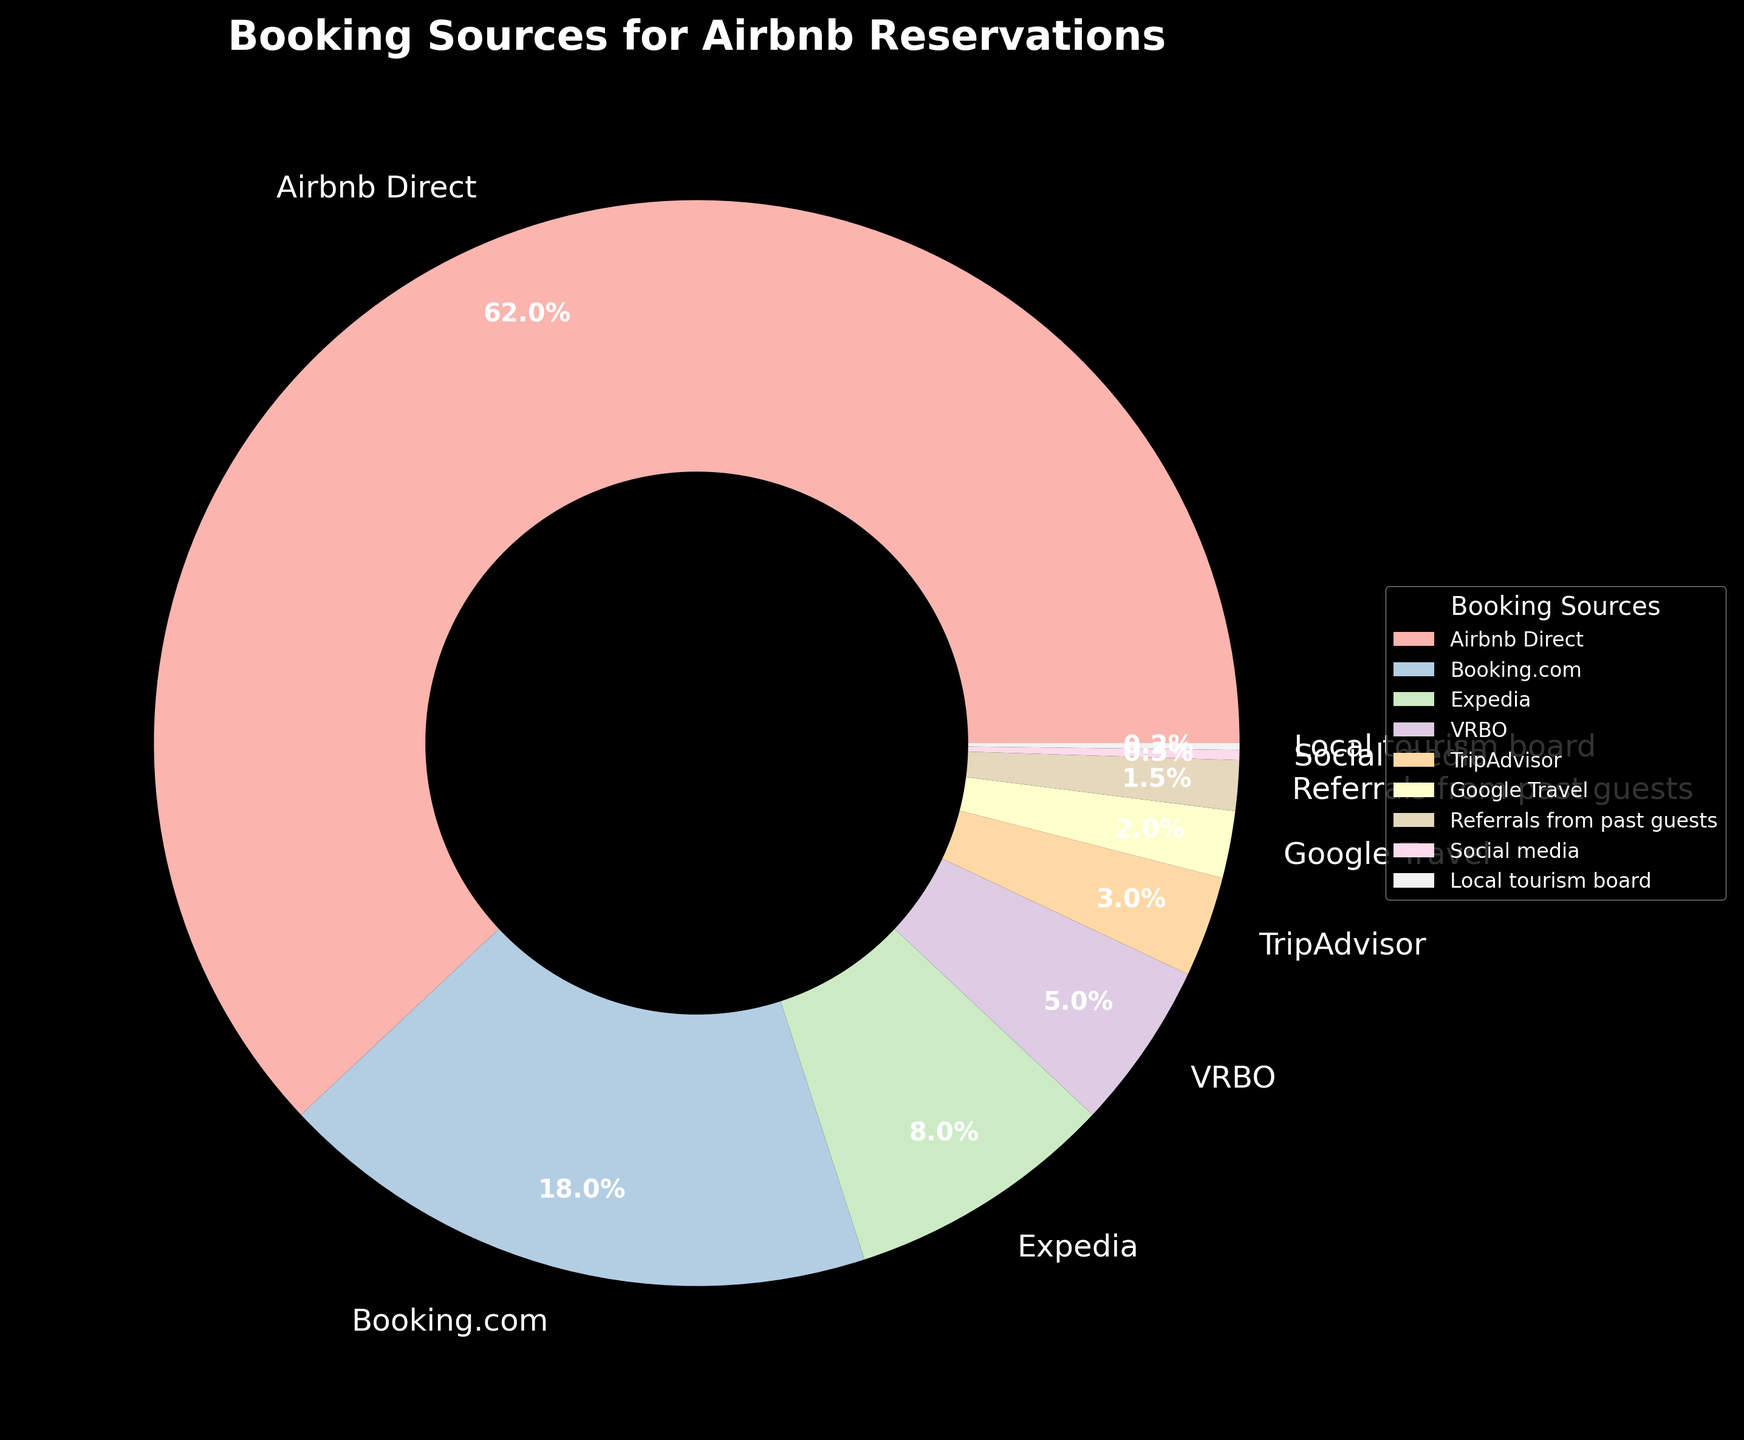What percentage of reservations come from referrals from past guests and social media combined? Referrals from past guests account for 1.5% and social media accounts for 0.3%. Summing them together gives 1.5% + 0.3% = 1.8%.
Answer: 1.8% Which booking source has the second highest percentage? The booking sources are listed with their respective percentages. After Airbnb Direct (62%), the next highest percentage is Booking.com with 18%.
Answer: Booking.com By how much does the percentage of Airbnb Direct bookings exceed the combined percentage of Expedia and VRBO? Airbnb Direct has 62%. Expedia and VRBO have 8% and 5% respectively, summing to 8% + 5% = 13%. The difference is 62% - 13% = 49%.
Answer: 49% Are the percentages of reservations from TripAdvisor and Google Travel together equal to, greater than, or less than the percentage from Expedia? TripAdvisor has 3% and Google Travel has 2%. Together they sum to 3% + 2% = 5%. Expedia by itself has 8%. Therefore, 5% is less than 8%.
Answer: Less than What portion of the pie chart is colored the same as the section representing Booking.com? The Booking.com section takes up 18% of the pie chart. To find the portion's color match, observe that this specific color is unique to Booking.com. So, only 18% of the chart is colored the same as Booking.com section.
Answer: 18% Which sources collectively make up less than 10% of all bookings? The sources less than 10% are: Expedia (8%), VRBO (5%), TripAdvisor (3%), Google Travel (2%), Referrals from past guests (1.5%), Social media (0.3%), and Local tourism board (0.2%). Summing these: 8% + 5% + 3% + 2% + 1.5% + 0.3% + 0.2% = 20%, but considering each individually, all are less than 10%.
Answer: Expedia, VRBO, TripAdvisor, Google Travel, Referrals from past guests, Social media, Local tourism board What is the visual feature that helps identify the booking source section for Social Media? The section for Social Media is identified by a specific small wedge on the pie chart, marked by its label and representing only 0.3% of the total reservations.
Answer: Small wedge and label Compare the total percentage of the top three sources to the rest of the booking sources combined. The top three sources are Airbnb Direct (62%), Booking.com (18%), and Expedia (8%), summing to 62% + 18% + 8% = 88%. The rest are 12% as they collectively make up 100% - 88% = 12%.
Answer: 88% vs 12% Which two booking sources have the smallest percentages and what are those percentages? The two smallest booking sources are Local tourism board with 0.2% and Social media with 0.3%.
Answer: 0.2% and 0.3% 